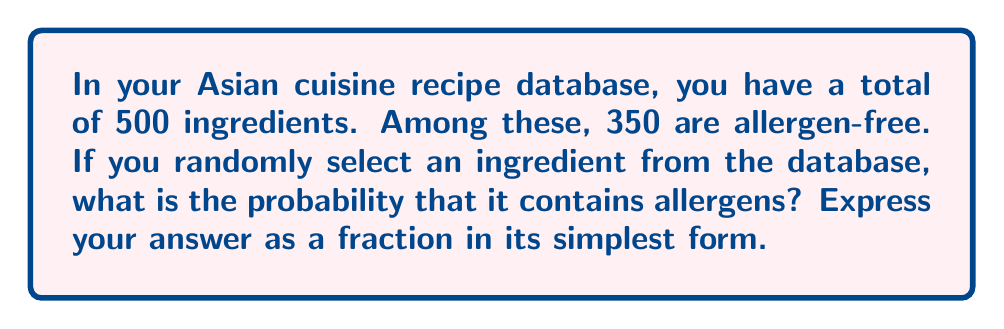Show me your answer to this math problem. Let's approach this step-by-step using set theory:

1) Let $U$ be the universal set of all ingredients in the database. 
   $|U| = 500$

2) Let $A$ be the set of allergen-free ingredients.
   $|A| = 350$

3) We need to find the complement of $A$, which we'll call $A^c$. This represents the set of ingredients that contain allergens.

4) The cardinality of $A^c$ can be found by subtracting the cardinality of $A$ from the cardinality of $U$:

   $|A^c| = |U| - |A| = 500 - 350 = 150$

5) The probability of selecting an ingredient that contains allergens is:

   $P(A^c) = \frac{|A^c|}{|U|} = \frac{150}{500}$

6) This fraction can be simplified by dividing both numerator and denominator by their greatest common divisor, which is 50:

   $\frac{150}{500} = \frac{150 \div 50}{500 \div 50} = \frac{3}{10}$

Therefore, the probability of randomly selecting an ingredient that contains allergens is $\frac{3}{10}$.
Answer: $\frac{3}{10}$ 